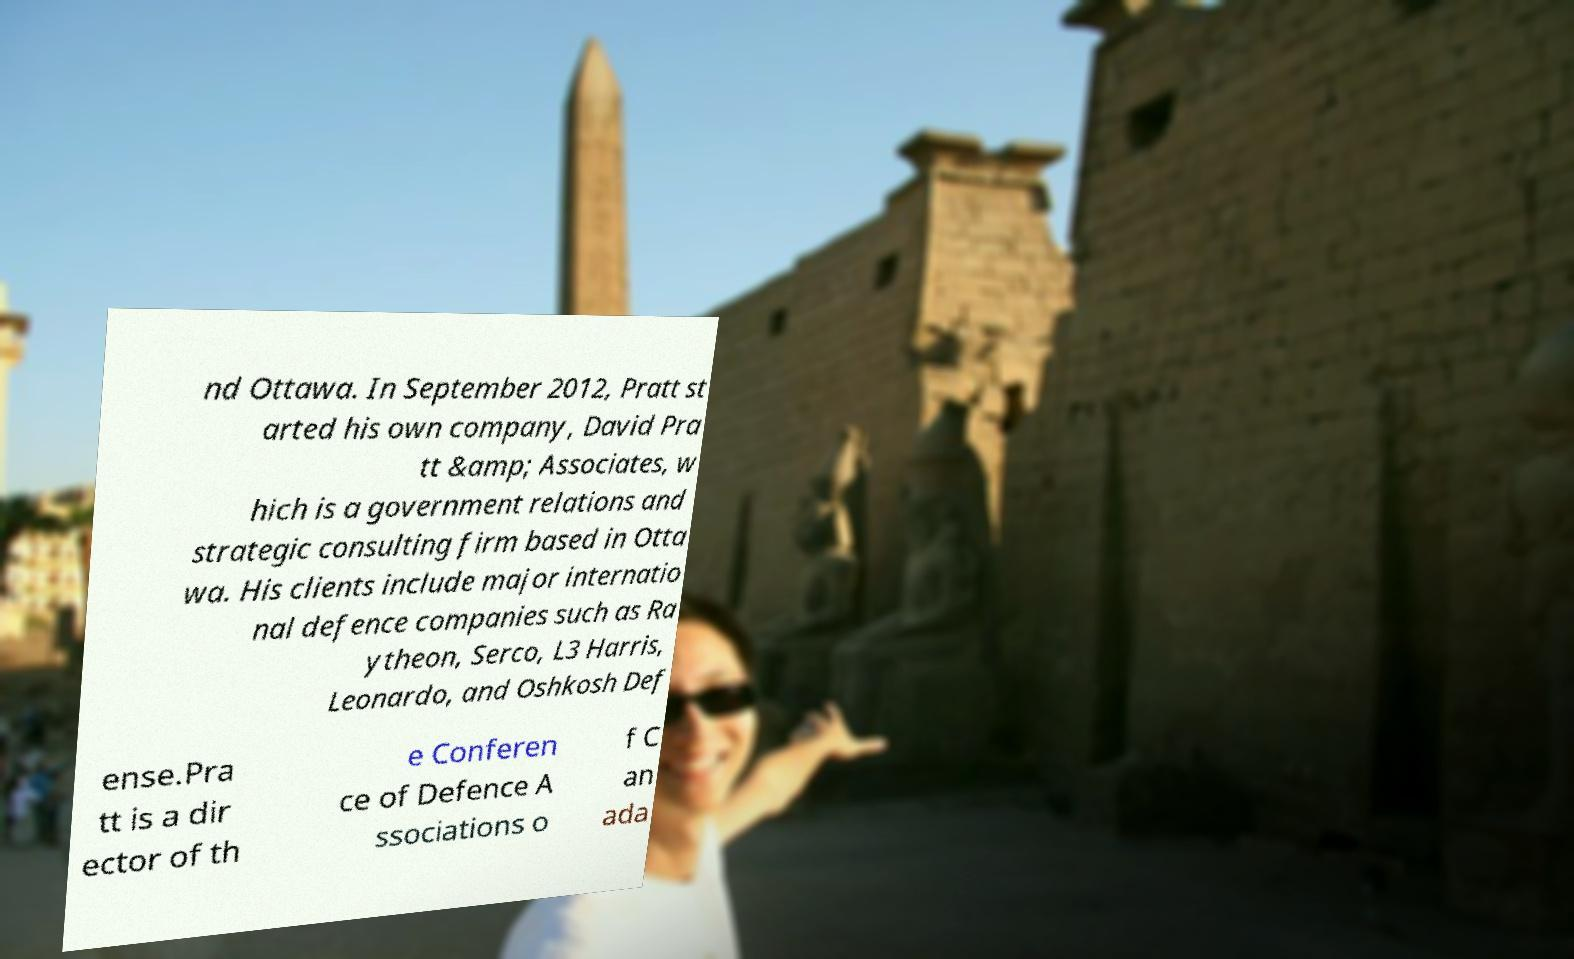Please read and relay the text visible in this image. What does it say? nd Ottawa. In September 2012, Pratt st arted his own company, David Pra tt &amp; Associates, w hich is a government relations and strategic consulting firm based in Otta wa. His clients include major internatio nal defence companies such as Ra ytheon, Serco, L3 Harris, Leonardo, and Oshkosh Def ense.Pra tt is a dir ector of th e Conferen ce of Defence A ssociations o f C an ada 